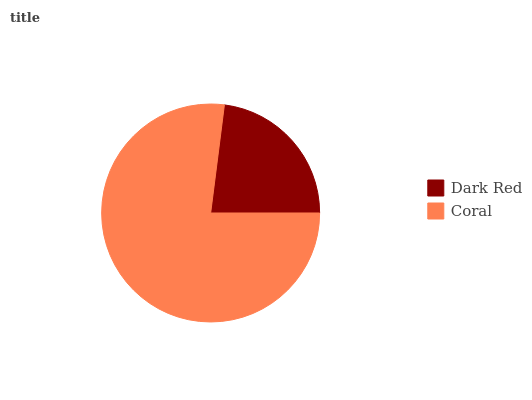Is Dark Red the minimum?
Answer yes or no. Yes. Is Coral the maximum?
Answer yes or no. Yes. Is Coral the minimum?
Answer yes or no. No. Is Coral greater than Dark Red?
Answer yes or no. Yes. Is Dark Red less than Coral?
Answer yes or no. Yes. Is Dark Red greater than Coral?
Answer yes or no. No. Is Coral less than Dark Red?
Answer yes or no. No. Is Coral the high median?
Answer yes or no. Yes. Is Dark Red the low median?
Answer yes or no. Yes. Is Dark Red the high median?
Answer yes or no. No. Is Coral the low median?
Answer yes or no. No. 